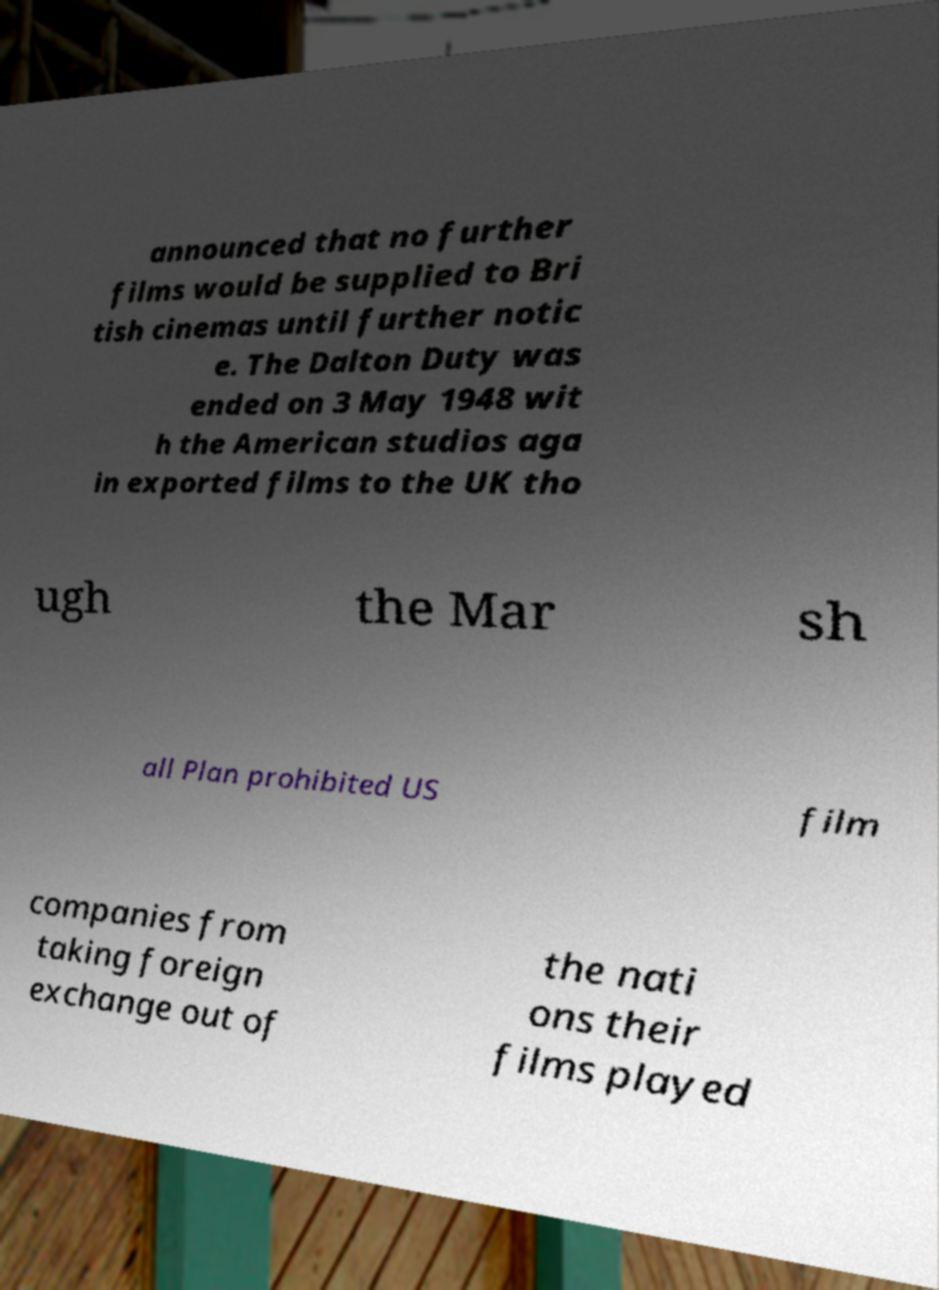Please identify and transcribe the text found in this image. announced that no further films would be supplied to Bri tish cinemas until further notic e. The Dalton Duty was ended on 3 May 1948 wit h the American studios aga in exported films to the UK tho ugh the Mar sh all Plan prohibited US film companies from taking foreign exchange out of the nati ons their films played 